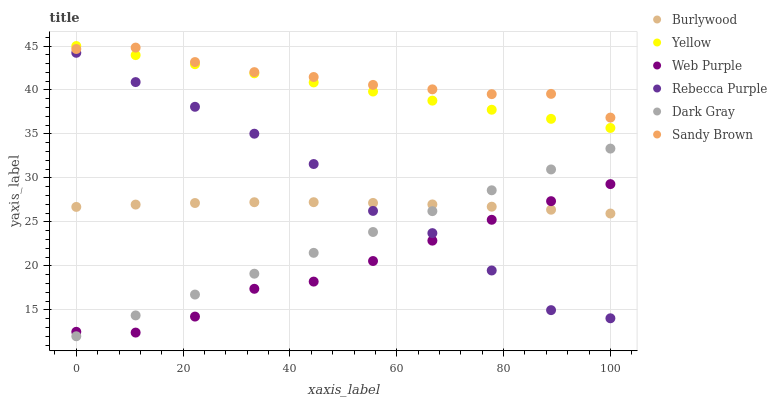Does Web Purple have the minimum area under the curve?
Answer yes or no. Yes. Does Sandy Brown have the maximum area under the curve?
Answer yes or no. Yes. Does Yellow have the minimum area under the curve?
Answer yes or no. No. Does Yellow have the maximum area under the curve?
Answer yes or no. No. Is Yellow the smoothest?
Answer yes or no. Yes. Is Rebecca Purple the roughest?
Answer yes or no. Yes. Is Dark Gray the smoothest?
Answer yes or no. No. Is Dark Gray the roughest?
Answer yes or no. No. Does Dark Gray have the lowest value?
Answer yes or no. Yes. Does Yellow have the lowest value?
Answer yes or no. No. Does Yellow have the highest value?
Answer yes or no. Yes. Does Dark Gray have the highest value?
Answer yes or no. No. Is Dark Gray less than Yellow?
Answer yes or no. Yes. Is Yellow greater than Burlywood?
Answer yes or no. Yes. Does Dark Gray intersect Burlywood?
Answer yes or no. Yes. Is Dark Gray less than Burlywood?
Answer yes or no. No. Is Dark Gray greater than Burlywood?
Answer yes or no. No. Does Dark Gray intersect Yellow?
Answer yes or no. No. 